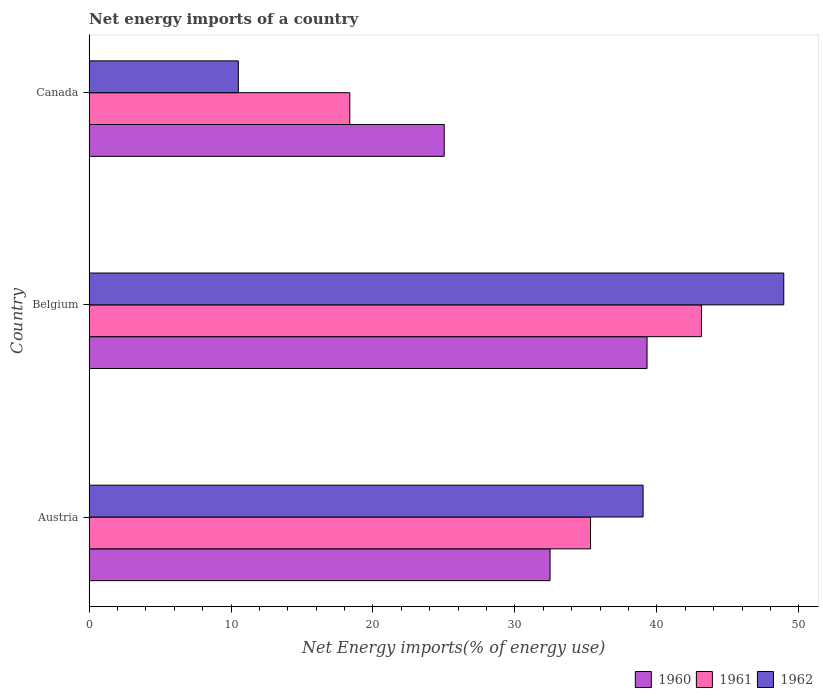How many groups of bars are there?
Keep it short and to the point. 3. Are the number of bars per tick equal to the number of legend labels?
Make the answer very short. Yes. What is the label of the 3rd group of bars from the top?
Provide a short and direct response. Austria. What is the net energy imports in 1960 in Austria?
Offer a very short reply. 32.48. Across all countries, what is the maximum net energy imports in 1962?
Make the answer very short. 48.94. Across all countries, what is the minimum net energy imports in 1960?
Your answer should be compact. 25.02. In which country was the net energy imports in 1961 maximum?
Offer a very short reply. Belgium. What is the total net energy imports in 1960 in the graph?
Keep it short and to the point. 96.8. What is the difference between the net energy imports in 1961 in Austria and that in Belgium?
Your answer should be very brief. -7.82. What is the difference between the net energy imports in 1962 in Canada and the net energy imports in 1960 in Austria?
Keep it short and to the point. -21.96. What is the average net energy imports in 1960 per country?
Keep it short and to the point. 32.27. What is the difference between the net energy imports in 1960 and net energy imports in 1961 in Austria?
Keep it short and to the point. -2.85. What is the ratio of the net energy imports in 1960 in Belgium to that in Canada?
Make the answer very short. 1.57. Is the net energy imports in 1961 in Austria less than that in Belgium?
Your answer should be compact. Yes. Is the difference between the net energy imports in 1960 in Austria and Canada greater than the difference between the net energy imports in 1961 in Austria and Canada?
Offer a very short reply. No. What is the difference between the highest and the second highest net energy imports in 1960?
Make the answer very short. 6.83. What is the difference between the highest and the lowest net energy imports in 1961?
Give a very brief answer. 24.78. Is it the case that in every country, the sum of the net energy imports in 1960 and net energy imports in 1962 is greater than the net energy imports in 1961?
Offer a terse response. Yes. How many countries are there in the graph?
Offer a very short reply. 3. Are the values on the major ticks of X-axis written in scientific E-notation?
Your answer should be very brief. No. Does the graph contain any zero values?
Provide a short and direct response. No. Where does the legend appear in the graph?
Provide a succinct answer. Bottom right. How many legend labels are there?
Your response must be concise. 3. How are the legend labels stacked?
Ensure brevity in your answer.  Horizontal. What is the title of the graph?
Make the answer very short. Net energy imports of a country. What is the label or title of the X-axis?
Your response must be concise. Net Energy imports(% of energy use). What is the Net Energy imports(% of energy use) in 1960 in Austria?
Your response must be concise. 32.48. What is the Net Energy imports(% of energy use) in 1961 in Austria?
Provide a short and direct response. 35.33. What is the Net Energy imports(% of energy use) in 1962 in Austria?
Your response must be concise. 39.03. What is the Net Energy imports(% of energy use) of 1960 in Belgium?
Keep it short and to the point. 39.31. What is the Net Energy imports(% of energy use) of 1961 in Belgium?
Offer a very short reply. 43.14. What is the Net Energy imports(% of energy use) in 1962 in Belgium?
Provide a succinct answer. 48.94. What is the Net Energy imports(% of energy use) in 1960 in Canada?
Provide a short and direct response. 25.02. What is the Net Energy imports(% of energy use) of 1961 in Canada?
Make the answer very short. 18.37. What is the Net Energy imports(% of energy use) of 1962 in Canada?
Offer a terse response. 10.52. Across all countries, what is the maximum Net Energy imports(% of energy use) in 1960?
Your answer should be compact. 39.31. Across all countries, what is the maximum Net Energy imports(% of energy use) of 1961?
Your answer should be very brief. 43.14. Across all countries, what is the maximum Net Energy imports(% of energy use) of 1962?
Your answer should be compact. 48.94. Across all countries, what is the minimum Net Energy imports(% of energy use) of 1960?
Provide a short and direct response. 25.02. Across all countries, what is the minimum Net Energy imports(% of energy use) of 1961?
Offer a very short reply. 18.37. Across all countries, what is the minimum Net Energy imports(% of energy use) of 1962?
Your answer should be compact. 10.52. What is the total Net Energy imports(% of energy use) of 1960 in the graph?
Provide a succinct answer. 96.8. What is the total Net Energy imports(% of energy use) in 1961 in the graph?
Offer a very short reply. 96.84. What is the total Net Energy imports(% of energy use) of 1962 in the graph?
Provide a succinct answer. 98.49. What is the difference between the Net Energy imports(% of energy use) of 1960 in Austria and that in Belgium?
Give a very brief answer. -6.83. What is the difference between the Net Energy imports(% of energy use) in 1961 in Austria and that in Belgium?
Ensure brevity in your answer.  -7.82. What is the difference between the Net Energy imports(% of energy use) of 1962 in Austria and that in Belgium?
Your answer should be very brief. -9.91. What is the difference between the Net Energy imports(% of energy use) in 1960 in Austria and that in Canada?
Your answer should be compact. 7.46. What is the difference between the Net Energy imports(% of energy use) in 1961 in Austria and that in Canada?
Keep it short and to the point. 16.96. What is the difference between the Net Energy imports(% of energy use) of 1962 in Austria and that in Canada?
Provide a short and direct response. 28.52. What is the difference between the Net Energy imports(% of energy use) in 1960 in Belgium and that in Canada?
Keep it short and to the point. 14.29. What is the difference between the Net Energy imports(% of energy use) of 1961 in Belgium and that in Canada?
Ensure brevity in your answer.  24.78. What is the difference between the Net Energy imports(% of energy use) of 1962 in Belgium and that in Canada?
Make the answer very short. 38.43. What is the difference between the Net Energy imports(% of energy use) in 1960 in Austria and the Net Energy imports(% of energy use) in 1961 in Belgium?
Offer a very short reply. -10.67. What is the difference between the Net Energy imports(% of energy use) in 1960 in Austria and the Net Energy imports(% of energy use) in 1962 in Belgium?
Provide a short and direct response. -16.46. What is the difference between the Net Energy imports(% of energy use) in 1961 in Austria and the Net Energy imports(% of energy use) in 1962 in Belgium?
Your answer should be compact. -13.61. What is the difference between the Net Energy imports(% of energy use) of 1960 in Austria and the Net Energy imports(% of energy use) of 1961 in Canada?
Your answer should be very brief. 14.11. What is the difference between the Net Energy imports(% of energy use) in 1960 in Austria and the Net Energy imports(% of energy use) in 1962 in Canada?
Provide a short and direct response. 21.96. What is the difference between the Net Energy imports(% of energy use) of 1961 in Austria and the Net Energy imports(% of energy use) of 1962 in Canada?
Your response must be concise. 24.81. What is the difference between the Net Energy imports(% of energy use) of 1960 in Belgium and the Net Energy imports(% of energy use) of 1961 in Canada?
Ensure brevity in your answer.  20.94. What is the difference between the Net Energy imports(% of energy use) in 1960 in Belgium and the Net Energy imports(% of energy use) in 1962 in Canada?
Provide a short and direct response. 28.79. What is the difference between the Net Energy imports(% of energy use) of 1961 in Belgium and the Net Energy imports(% of energy use) of 1962 in Canada?
Provide a succinct answer. 32.63. What is the average Net Energy imports(% of energy use) in 1960 per country?
Your response must be concise. 32.27. What is the average Net Energy imports(% of energy use) of 1961 per country?
Keep it short and to the point. 32.28. What is the average Net Energy imports(% of energy use) of 1962 per country?
Give a very brief answer. 32.83. What is the difference between the Net Energy imports(% of energy use) of 1960 and Net Energy imports(% of energy use) of 1961 in Austria?
Ensure brevity in your answer.  -2.85. What is the difference between the Net Energy imports(% of energy use) in 1960 and Net Energy imports(% of energy use) in 1962 in Austria?
Keep it short and to the point. -6.55. What is the difference between the Net Energy imports(% of energy use) of 1961 and Net Energy imports(% of energy use) of 1962 in Austria?
Offer a terse response. -3.7. What is the difference between the Net Energy imports(% of energy use) of 1960 and Net Energy imports(% of energy use) of 1961 in Belgium?
Offer a terse response. -3.83. What is the difference between the Net Energy imports(% of energy use) of 1960 and Net Energy imports(% of energy use) of 1962 in Belgium?
Give a very brief answer. -9.63. What is the difference between the Net Energy imports(% of energy use) of 1961 and Net Energy imports(% of energy use) of 1962 in Belgium?
Keep it short and to the point. -5.8. What is the difference between the Net Energy imports(% of energy use) in 1960 and Net Energy imports(% of energy use) in 1961 in Canada?
Offer a very short reply. 6.65. What is the difference between the Net Energy imports(% of energy use) of 1960 and Net Energy imports(% of energy use) of 1962 in Canada?
Provide a short and direct response. 14.5. What is the difference between the Net Energy imports(% of energy use) of 1961 and Net Energy imports(% of energy use) of 1962 in Canada?
Your response must be concise. 7.85. What is the ratio of the Net Energy imports(% of energy use) of 1960 in Austria to that in Belgium?
Your answer should be very brief. 0.83. What is the ratio of the Net Energy imports(% of energy use) of 1961 in Austria to that in Belgium?
Give a very brief answer. 0.82. What is the ratio of the Net Energy imports(% of energy use) in 1962 in Austria to that in Belgium?
Offer a terse response. 0.8. What is the ratio of the Net Energy imports(% of energy use) of 1960 in Austria to that in Canada?
Your answer should be compact. 1.3. What is the ratio of the Net Energy imports(% of energy use) of 1961 in Austria to that in Canada?
Keep it short and to the point. 1.92. What is the ratio of the Net Energy imports(% of energy use) of 1962 in Austria to that in Canada?
Provide a short and direct response. 3.71. What is the ratio of the Net Energy imports(% of energy use) in 1960 in Belgium to that in Canada?
Provide a succinct answer. 1.57. What is the ratio of the Net Energy imports(% of energy use) in 1961 in Belgium to that in Canada?
Give a very brief answer. 2.35. What is the ratio of the Net Energy imports(% of energy use) in 1962 in Belgium to that in Canada?
Provide a succinct answer. 4.65. What is the difference between the highest and the second highest Net Energy imports(% of energy use) in 1960?
Offer a very short reply. 6.83. What is the difference between the highest and the second highest Net Energy imports(% of energy use) of 1961?
Provide a short and direct response. 7.82. What is the difference between the highest and the second highest Net Energy imports(% of energy use) of 1962?
Ensure brevity in your answer.  9.91. What is the difference between the highest and the lowest Net Energy imports(% of energy use) in 1960?
Offer a very short reply. 14.29. What is the difference between the highest and the lowest Net Energy imports(% of energy use) of 1961?
Your answer should be compact. 24.78. What is the difference between the highest and the lowest Net Energy imports(% of energy use) of 1962?
Give a very brief answer. 38.43. 